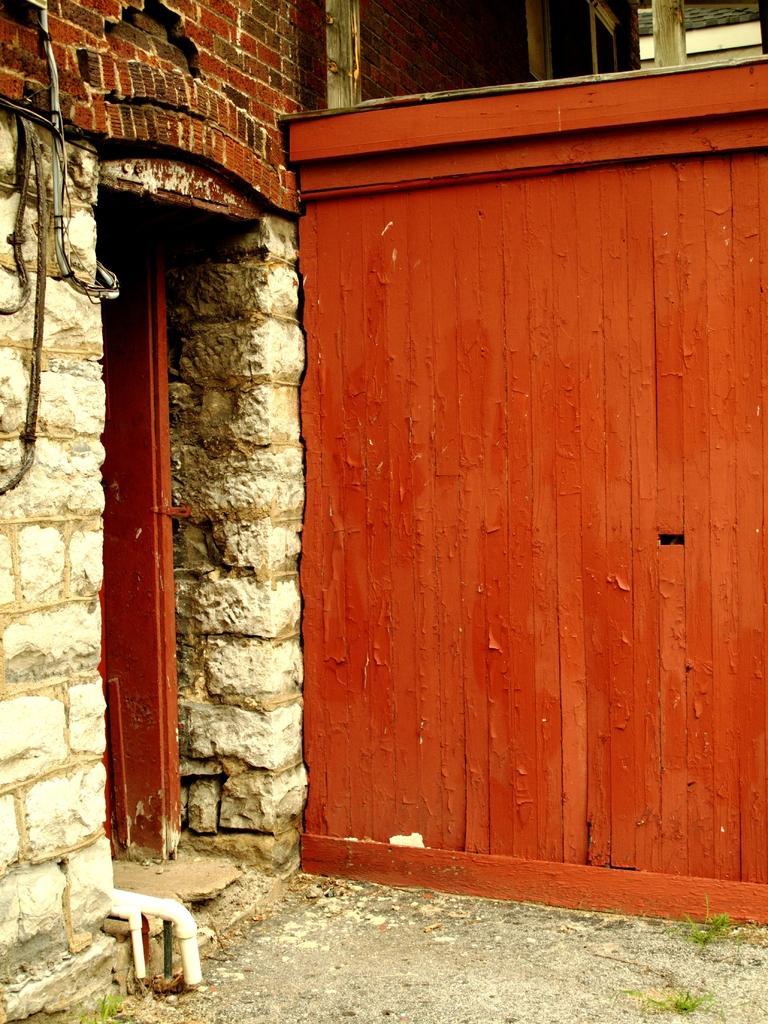Describe this image in one or two sentences. In this image, we can see a wall and there is a door and we can see some pipes. At the bottom, there is ground. 